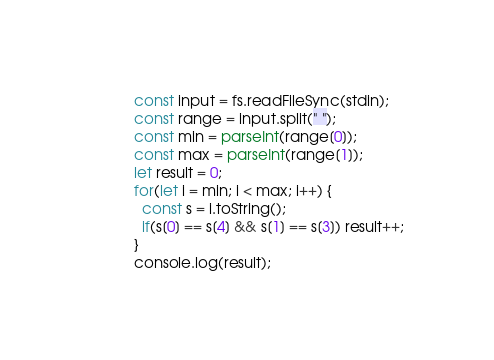Convert code to text. <code><loc_0><loc_0><loc_500><loc_500><_JavaScript_>const input = fs.readFileSync(stdin);
const range = input.split(" ");
const min = parseInt(range[0]);
const max = parseInt(range[1]);
let result = 0;
for(let i = min; i < max; i++) {
  const s = i.toString();
  if(s[0] == s[4] && s[1] == s[3]) result++;
}
console.log(result);</code> 